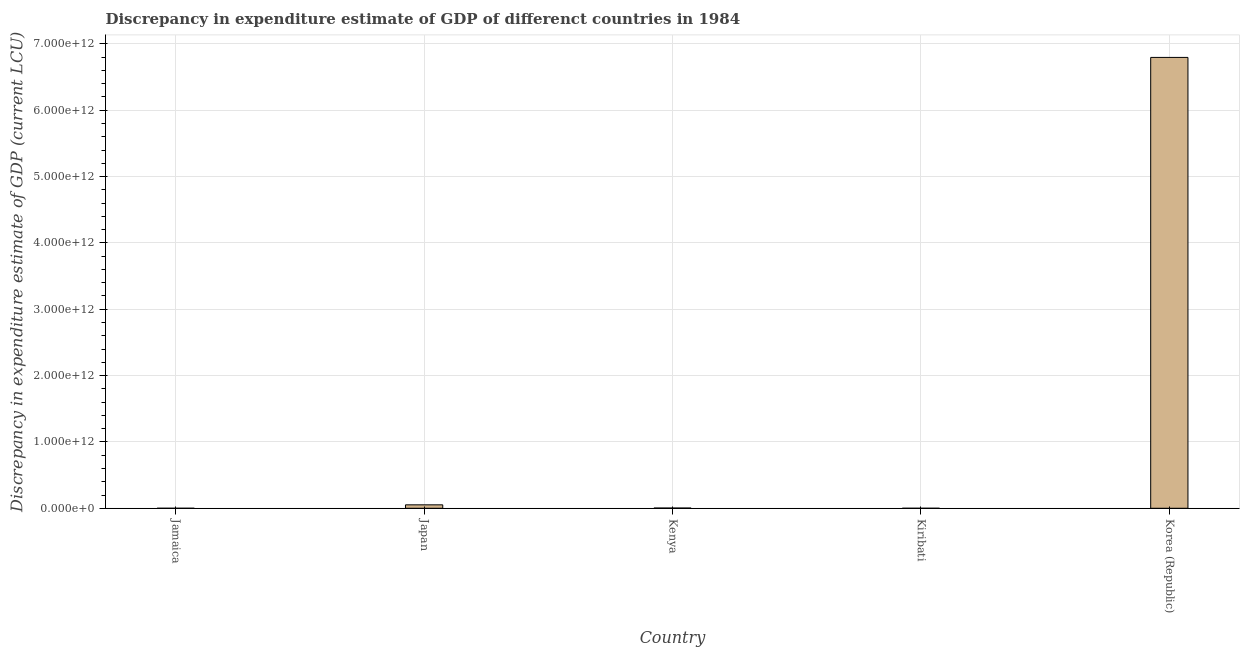Does the graph contain any zero values?
Your answer should be compact. No. What is the title of the graph?
Give a very brief answer. Discrepancy in expenditure estimate of GDP of differenct countries in 1984. What is the label or title of the X-axis?
Your answer should be very brief. Country. What is the label or title of the Y-axis?
Your answer should be very brief. Discrepancy in expenditure estimate of GDP (current LCU). What is the discrepancy in expenditure estimate of gdp in Korea (Republic)?
Provide a succinct answer. 6.80e+12. Across all countries, what is the maximum discrepancy in expenditure estimate of gdp?
Give a very brief answer. 6.80e+12. Across all countries, what is the minimum discrepancy in expenditure estimate of gdp?
Provide a succinct answer. 9.96e+04. In which country was the discrepancy in expenditure estimate of gdp minimum?
Offer a terse response. Jamaica. What is the sum of the discrepancy in expenditure estimate of gdp?
Provide a succinct answer. 6.85e+12. What is the difference between the discrepancy in expenditure estimate of gdp in Kiribati and Korea (Republic)?
Provide a succinct answer. -6.80e+12. What is the average discrepancy in expenditure estimate of gdp per country?
Make the answer very short. 1.37e+12. What is the median discrepancy in expenditure estimate of gdp?
Your response must be concise. 3.47e+09. In how many countries, is the discrepancy in expenditure estimate of gdp greater than 5200000000000 LCU?
Your answer should be compact. 1. What is the ratio of the discrepancy in expenditure estimate of gdp in Japan to that in Kenya?
Your answer should be very brief. 14.96. Is the discrepancy in expenditure estimate of gdp in Japan less than that in Kenya?
Give a very brief answer. No. Is the difference between the discrepancy in expenditure estimate of gdp in Kiribati and Korea (Republic) greater than the difference between any two countries?
Give a very brief answer. No. What is the difference between the highest and the second highest discrepancy in expenditure estimate of gdp?
Your response must be concise. 6.74e+12. Is the sum of the discrepancy in expenditure estimate of gdp in Jamaica and Kiribati greater than the maximum discrepancy in expenditure estimate of gdp across all countries?
Give a very brief answer. No. What is the difference between the highest and the lowest discrepancy in expenditure estimate of gdp?
Offer a terse response. 6.80e+12. Are all the bars in the graph horizontal?
Your answer should be compact. No. How many countries are there in the graph?
Provide a short and direct response. 5. What is the difference between two consecutive major ticks on the Y-axis?
Your answer should be very brief. 1.00e+12. Are the values on the major ticks of Y-axis written in scientific E-notation?
Make the answer very short. Yes. What is the Discrepancy in expenditure estimate of GDP (current LCU) in Jamaica?
Provide a succinct answer. 9.96e+04. What is the Discrepancy in expenditure estimate of GDP (current LCU) of Japan?
Provide a short and direct response. 5.19e+1. What is the Discrepancy in expenditure estimate of GDP (current LCU) of Kenya?
Provide a short and direct response. 3.47e+09. What is the Discrepancy in expenditure estimate of GDP (current LCU) in Kiribati?
Your answer should be very brief. 2.16e+06. What is the Discrepancy in expenditure estimate of GDP (current LCU) in Korea (Republic)?
Offer a terse response. 6.80e+12. What is the difference between the Discrepancy in expenditure estimate of GDP (current LCU) in Jamaica and Japan?
Keep it short and to the point. -5.19e+1. What is the difference between the Discrepancy in expenditure estimate of GDP (current LCU) in Jamaica and Kenya?
Offer a very short reply. -3.47e+09. What is the difference between the Discrepancy in expenditure estimate of GDP (current LCU) in Jamaica and Kiribati?
Your answer should be compact. -2.06e+06. What is the difference between the Discrepancy in expenditure estimate of GDP (current LCU) in Jamaica and Korea (Republic)?
Your answer should be compact. -6.80e+12. What is the difference between the Discrepancy in expenditure estimate of GDP (current LCU) in Japan and Kenya?
Give a very brief answer. 4.84e+1. What is the difference between the Discrepancy in expenditure estimate of GDP (current LCU) in Japan and Kiribati?
Offer a very short reply. 5.19e+1. What is the difference between the Discrepancy in expenditure estimate of GDP (current LCU) in Japan and Korea (Republic)?
Offer a very short reply. -6.74e+12. What is the difference between the Discrepancy in expenditure estimate of GDP (current LCU) in Kenya and Kiribati?
Offer a terse response. 3.47e+09. What is the difference between the Discrepancy in expenditure estimate of GDP (current LCU) in Kenya and Korea (Republic)?
Ensure brevity in your answer.  -6.79e+12. What is the difference between the Discrepancy in expenditure estimate of GDP (current LCU) in Kiribati and Korea (Republic)?
Your response must be concise. -6.80e+12. What is the ratio of the Discrepancy in expenditure estimate of GDP (current LCU) in Jamaica to that in Japan?
Your answer should be compact. 0. What is the ratio of the Discrepancy in expenditure estimate of GDP (current LCU) in Jamaica to that in Kenya?
Your response must be concise. 0. What is the ratio of the Discrepancy in expenditure estimate of GDP (current LCU) in Jamaica to that in Kiribati?
Your answer should be very brief. 0.05. What is the ratio of the Discrepancy in expenditure estimate of GDP (current LCU) in Jamaica to that in Korea (Republic)?
Keep it short and to the point. 0. What is the ratio of the Discrepancy in expenditure estimate of GDP (current LCU) in Japan to that in Kenya?
Ensure brevity in your answer.  14.96. What is the ratio of the Discrepancy in expenditure estimate of GDP (current LCU) in Japan to that in Kiribati?
Provide a succinct answer. 2.41e+04. What is the ratio of the Discrepancy in expenditure estimate of GDP (current LCU) in Japan to that in Korea (Republic)?
Your answer should be compact. 0.01. What is the ratio of the Discrepancy in expenditure estimate of GDP (current LCU) in Kenya to that in Kiribati?
Make the answer very short. 1609.43. What is the ratio of the Discrepancy in expenditure estimate of GDP (current LCU) in Kenya to that in Korea (Republic)?
Offer a terse response. 0. What is the ratio of the Discrepancy in expenditure estimate of GDP (current LCU) in Kiribati to that in Korea (Republic)?
Give a very brief answer. 0. 